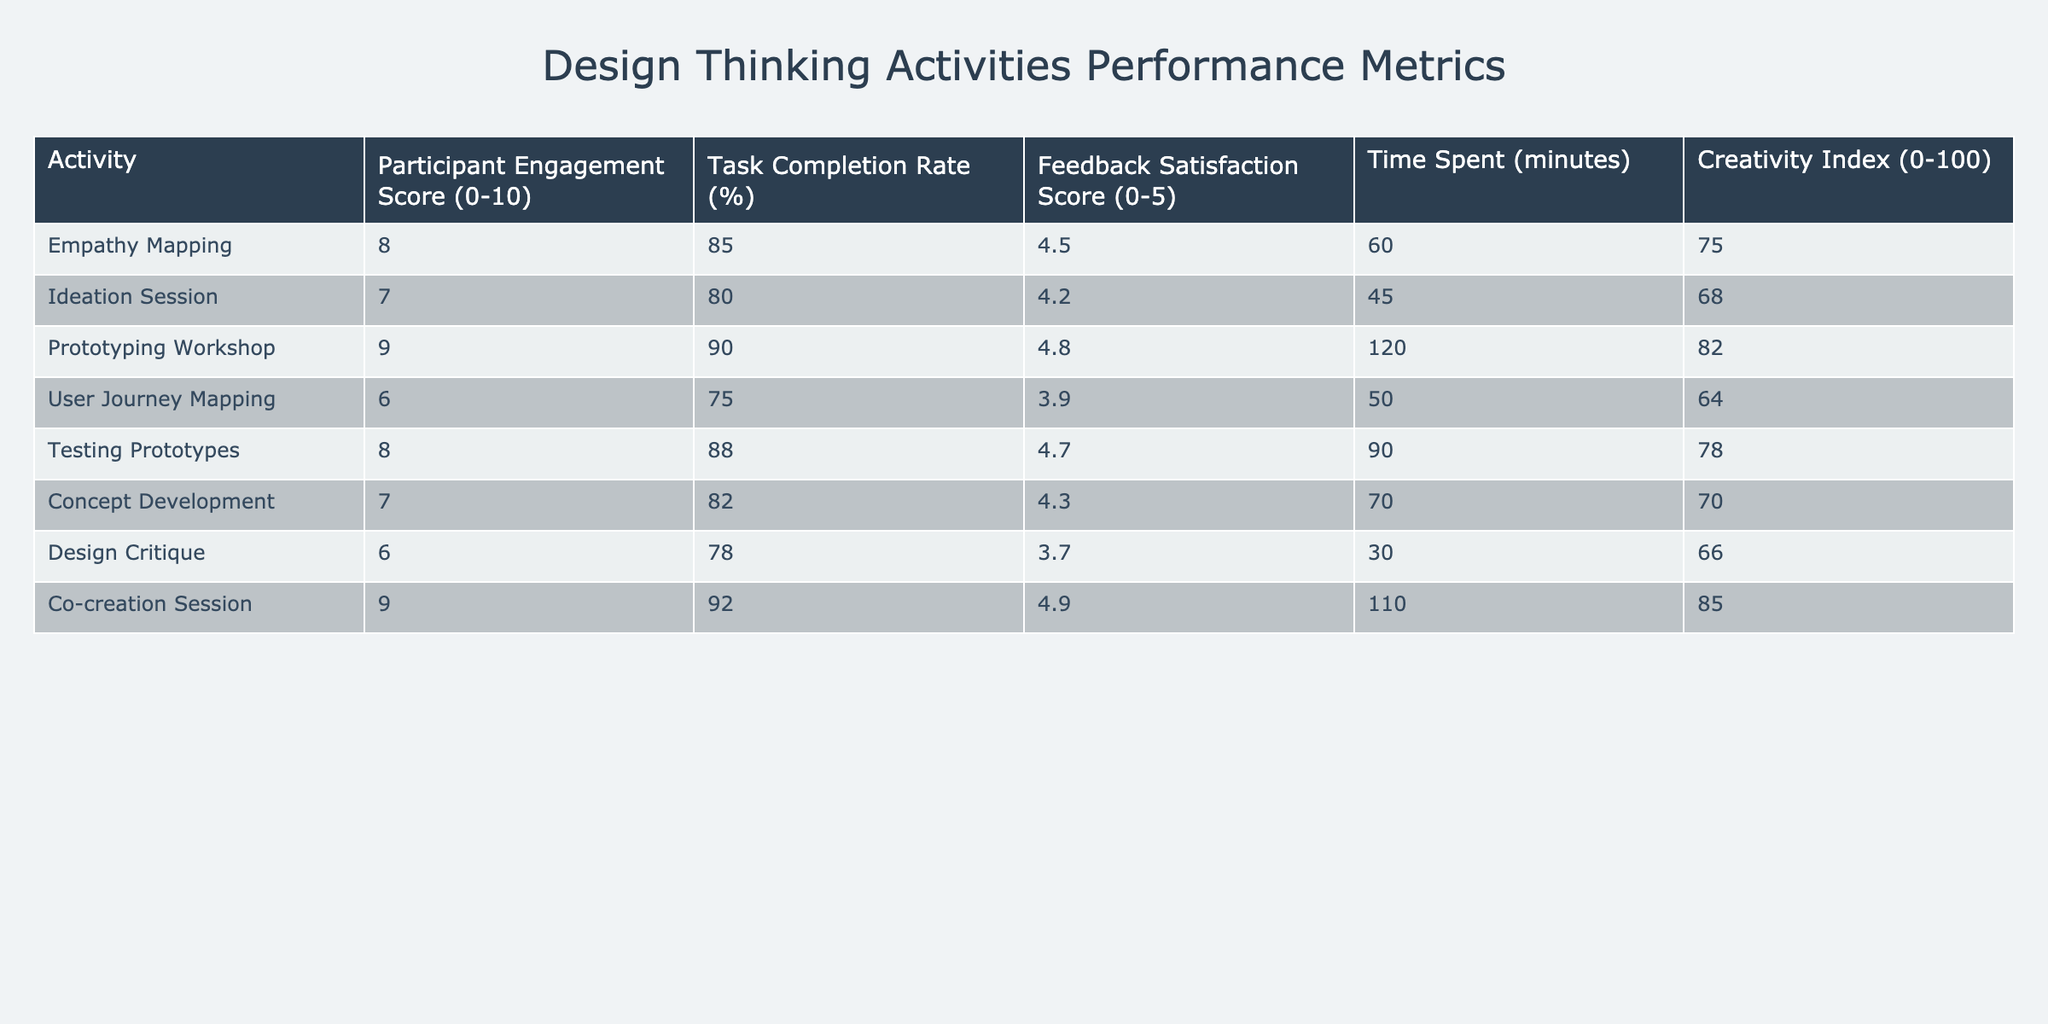What is the highest Participant Engagement Score? The Participant Engagement Score for each activity is listed in the table. The maximum score is 9, which appears for the Prototyping Workshop and Co-creation Session.
Answer: 9 What is the average Task Completion Rate for all activities? To find the average Task Completion Rate, add all the percentages together: 85 + 80 + 90 + 75 + 88 + 82 + 78 + 92 = 720. There are 8 activities, so the average is 720/8 = 90.
Answer: 90 Is the Feedback Satisfaction Score for User Journey Mapping greater than 4? The Feedback Satisfaction Score for User Journey Mapping is 3.9, which is less than 4.
Answer: No Which activity spent the most time in minutes? Comparing the Time Spent values: the Prototyping Workshop spent 120 minutes, which is greater than all other activities.
Answer: Prototyping Workshop What is the difference in Creativity Index between the highest and lowest scored activities? The highest Creativity Index is 85 (Co-creation Session), and the lowest is 64 (User Journey Mapping). The difference is 85 - 64 = 21.
Answer: 21 Does the Ideation Session have a Task Completion Rate higher than the average? The average Task Completion Rate, calculated previously, is 90. The Task Completion Rate for the Ideation Session is 80, which is lower than the average.
Answer: No What is the total Feedback Satisfaction Score for all activities? The total Feedback Satisfaction Score can be found by summing the individual scores: 4.5 + 4.2 + 4.8 + 3.9 + 4.7 + 4.3 + 3.7 + 4.9 = 36.0.
Answer: 36.0 Which activity has the lowest Creativity Index? The Creativity Index is lowest for User Journey Mapping, which has a score of 64, compared to other activities listed.
Answer: User Journey Mapping What percentage of the activities have a Task Completion Rate of 85% or higher? There are 5 activities with a Task Completion Rate of 85% or higher: Empathy Mapping, Prototyping Workshop, Testing Prototypes, Co-creation Session (4 out of 8 activities). The percentage is (4/8)*100 = 50%.
Answer: 50% 